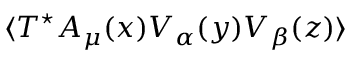Convert formula to latex. <formula><loc_0><loc_0><loc_500><loc_500>\langle T ^ { ^ { * } } A _ { \mu } ( x ) V _ { \alpha } ( y ) V _ { \beta } ( z ) \rangle</formula> 